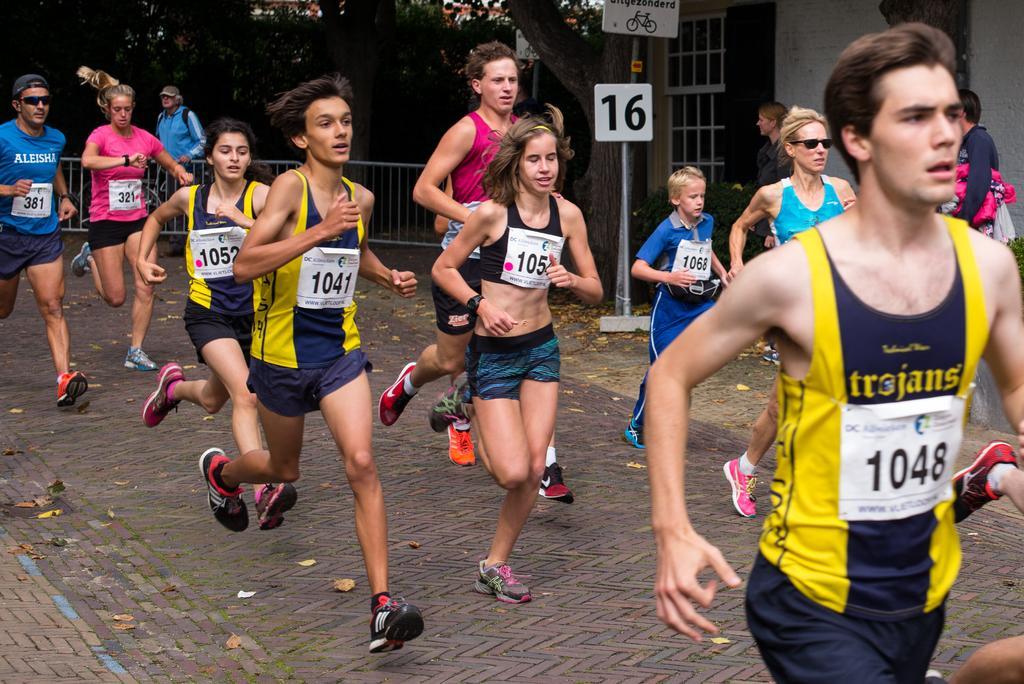Could you give a brief overview of what you see in this image? In this image we can see people running and we can also see a stand, fence and trees. 